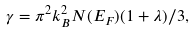Convert formula to latex. <formula><loc_0><loc_0><loc_500><loc_500>\gamma = \pi ^ { 2 } k _ { B } ^ { 2 } N ( E _ { F } ) ( 1 + \lambda ) / 3 ,</formula> 